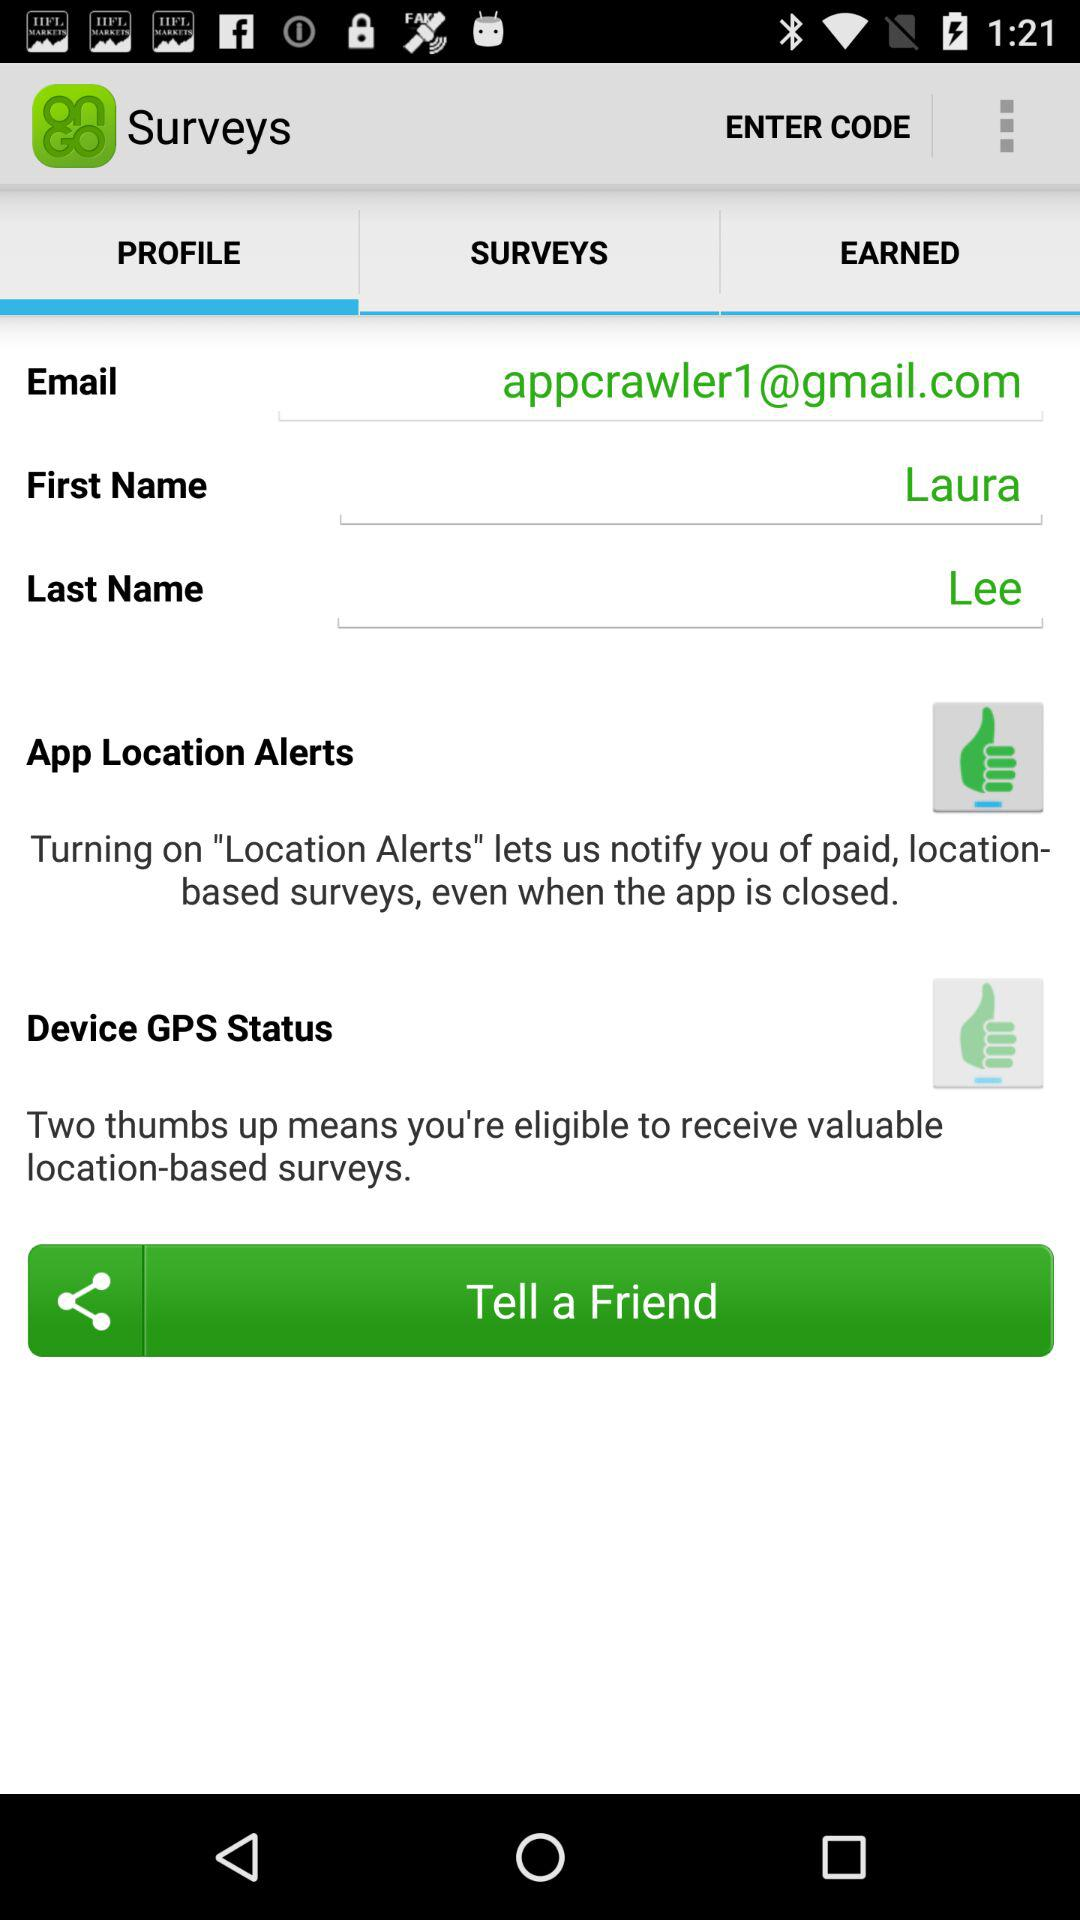What is meant by two thumbs up? Two thumbs up means you're eligible to receive valuable location-based surveys. 